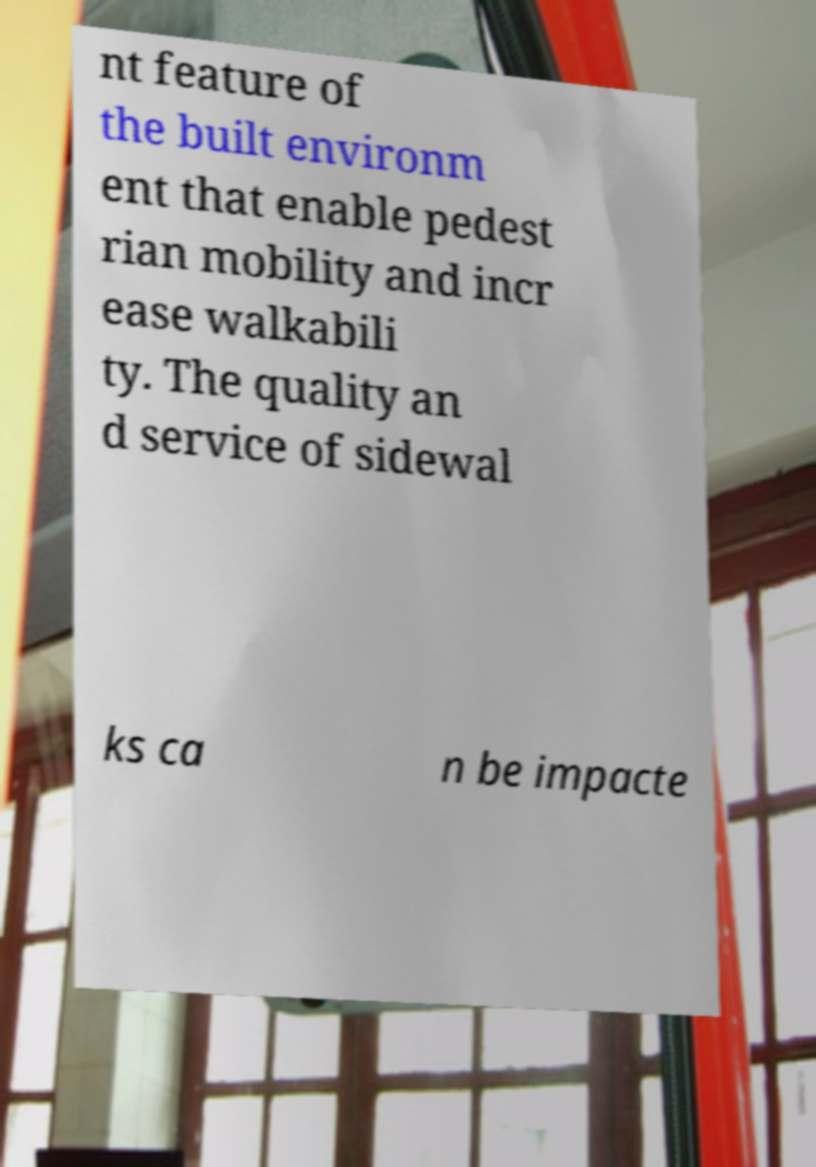For documentation purposes, I need the text within this image transcribed. Could you provide that? nt feature of the built environm ent that enable pedest rian mobility and incr ease walkabili ty. The quality an d service of sidewal ks ca n be impacte 